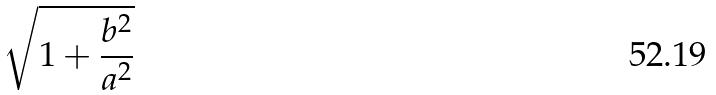<formula> <loc_0><loc_0><loc_500><loc_500>\sqrt { 1 + \frac { b ^ { 2 } } { a ^ { 2 } } }</formula> 